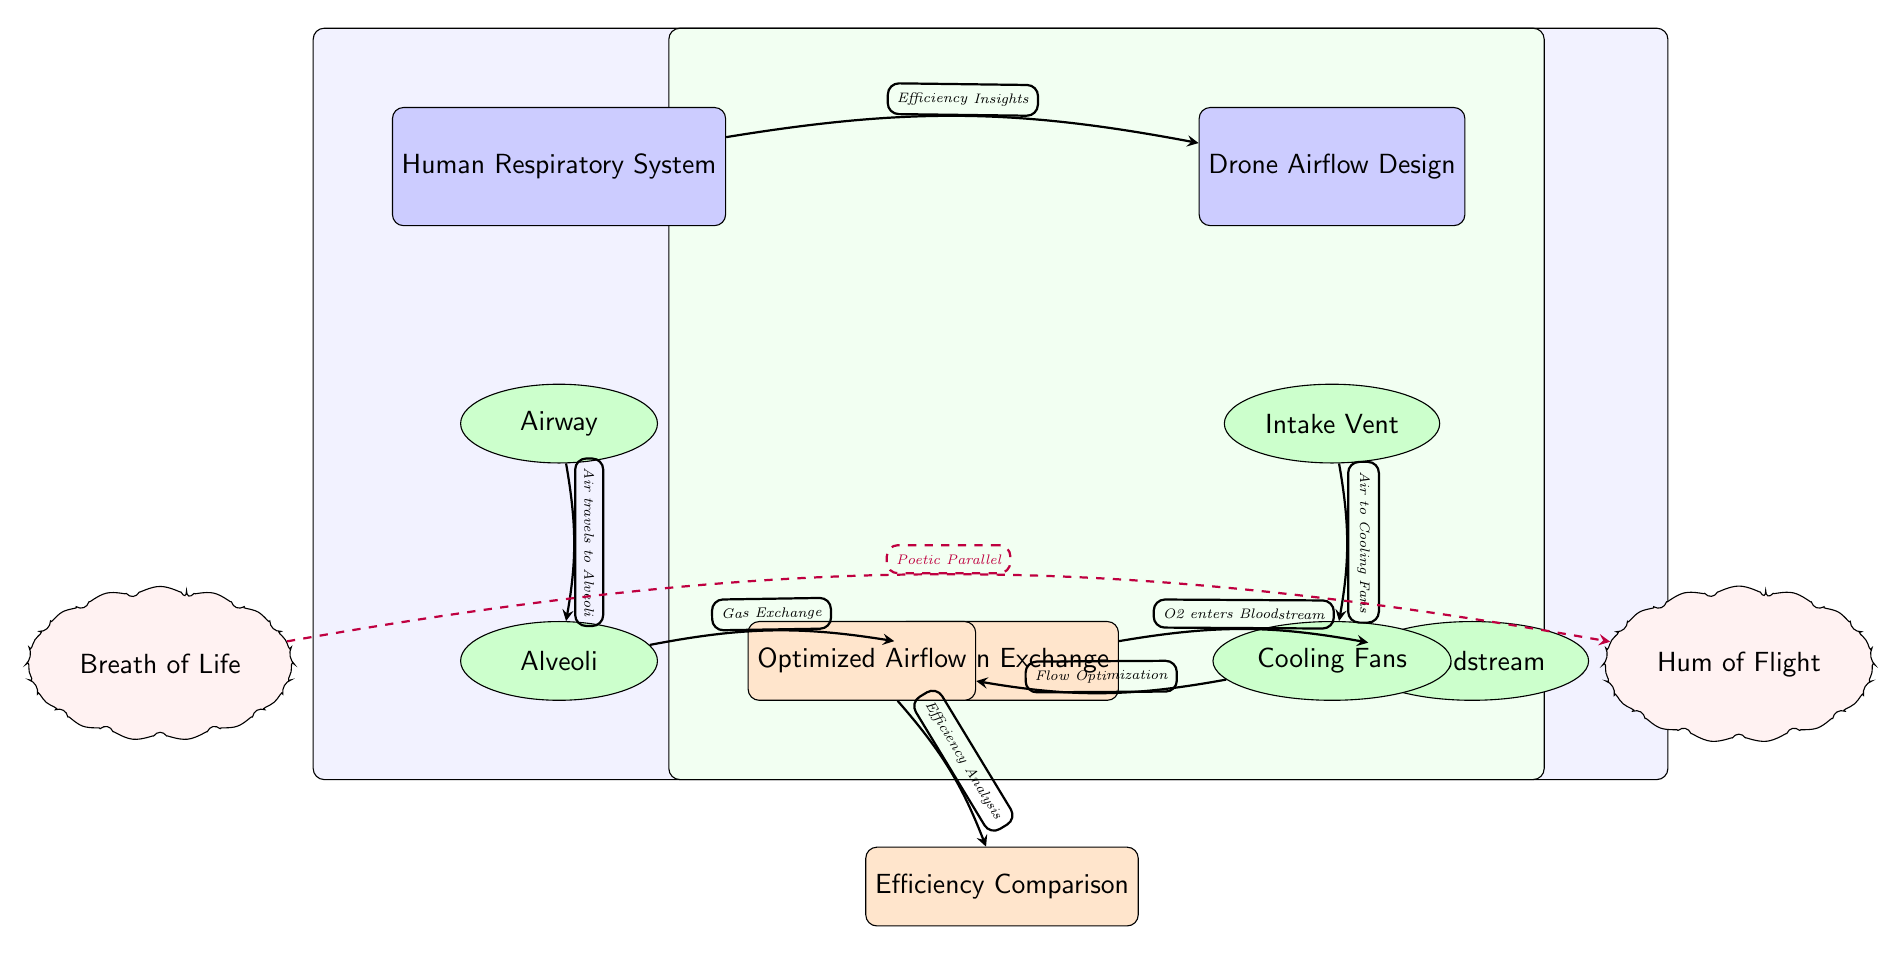What are the two main systems depicted in the diagram? The diagram illustrates the Human Respiratory System and Drone Airflow Design, both represented as main nodes. By looking at the diagram, you can directly identify these blocks labeled as "Human Respiratory System" and "Drone Airflow Design."
Answer: Human Respiratory System and Drone Airflow Design What process occurs in the alveoli? The diagram shows an arrow leading from "Alveoli" to "Oxygen Exchange," indicating that gas exchange occurs in the alveoli. This means that the primary function depicted for the alveoli is the exchange of gases.
Answer: Oxygen Exchange How many poetic elements are depicted in the diagram? The diagram includes two poetic elements: "Breath of Life" and "Hum of Flight," which are represented as cloud-shaped nodes. Counting these nodes in the bottom left and bottom right sections provides the answer.
Answer: 2 What connects the airflow in drones to the efficiency of the respiratory system? The arrow labeled "Efficiency Insights" connects the "Human Respiratory System" node to the "Drone Airflow Design" node, suggesting that insights about the efficiency of the respiratory system can inform drone design. Thus, it shows a comparative link between the two systems regarding efficiency.
Answer: Efficiency Insights Which component of the drone is responsible for air intake? The diagram indicates "Intake Vent" as the first subcomponent under "Drone Airflow Design," clearly labeling it to signify that it is responsible for air intake into the drone system. Looking at the flow structure, this becomes evident.
Answer: Intake Vent What type of connection is shown between "Breath of Life" and "Hum of Flight"? The connection between the nodes "Breath of Life" and "Hum of Flight" is represented by a dashed arrow labeled "Poetic Parallel," which symbolizes a conceptual relationship rather than a direct functional flow. This unique connection reflects a thematic link, emphasizing their relationship through poetic imagery.
Answer: Poetic Parallel What is the output of the airflow after it passes through the cooling fans? After the "Cooling Fans" node, there's an arrow labeled "Flow Optimization" leading to the "Optimized Airflow," indicating that airflow is optimized after passing through the fans. The process enhances efficiency in the airflow design.
Answer: Optimized Airflow Which component directly contributes to the exchange of gases? The diagram denotes "Exchange" as the processing node immediately following "Alveoli," indicating its primary role in gas exchange within the respiratory system. Therefore, this component is crucial for the transfer of oxygen and carbon dioxide.
Answer: Exchange 